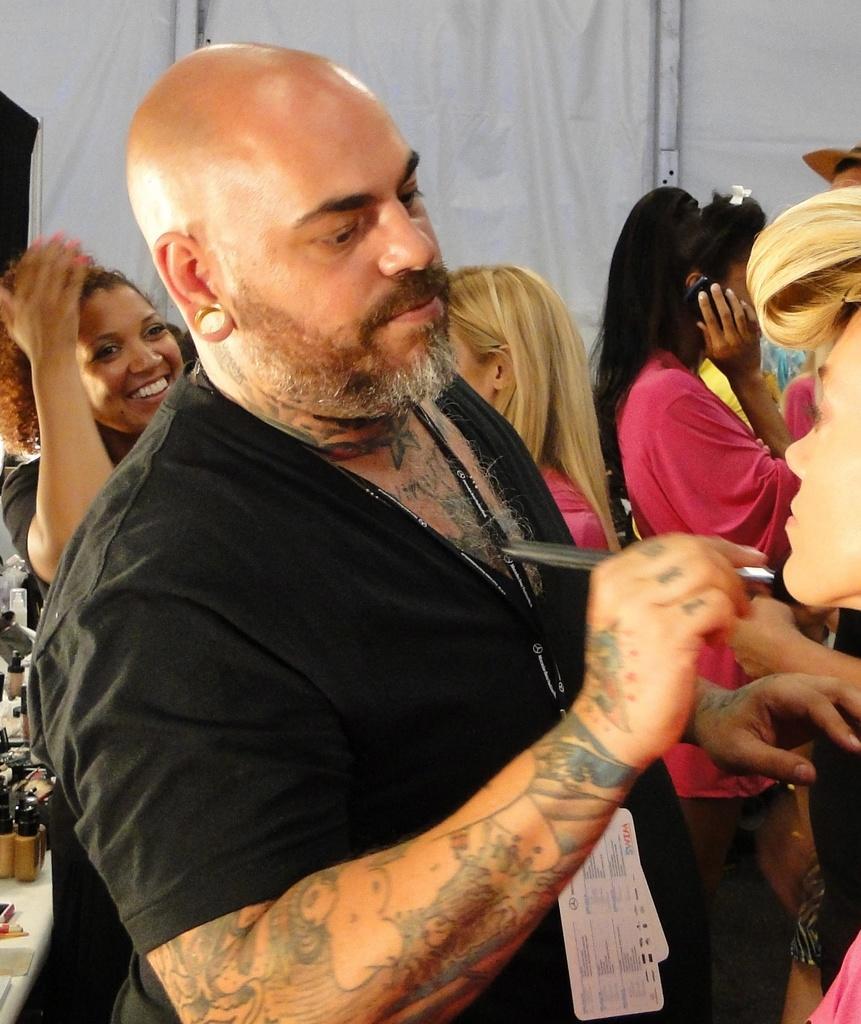How would you summarize this image in a sentence or two? In this picture we can observe a man wearing black color shirt and a tag in his neck. He is holding a makeup brush in his hand. We can observe tattoo on his hand. Behind him there is a woman smiling. We can observe some women in this picture. In the background there is a white color curtain. 